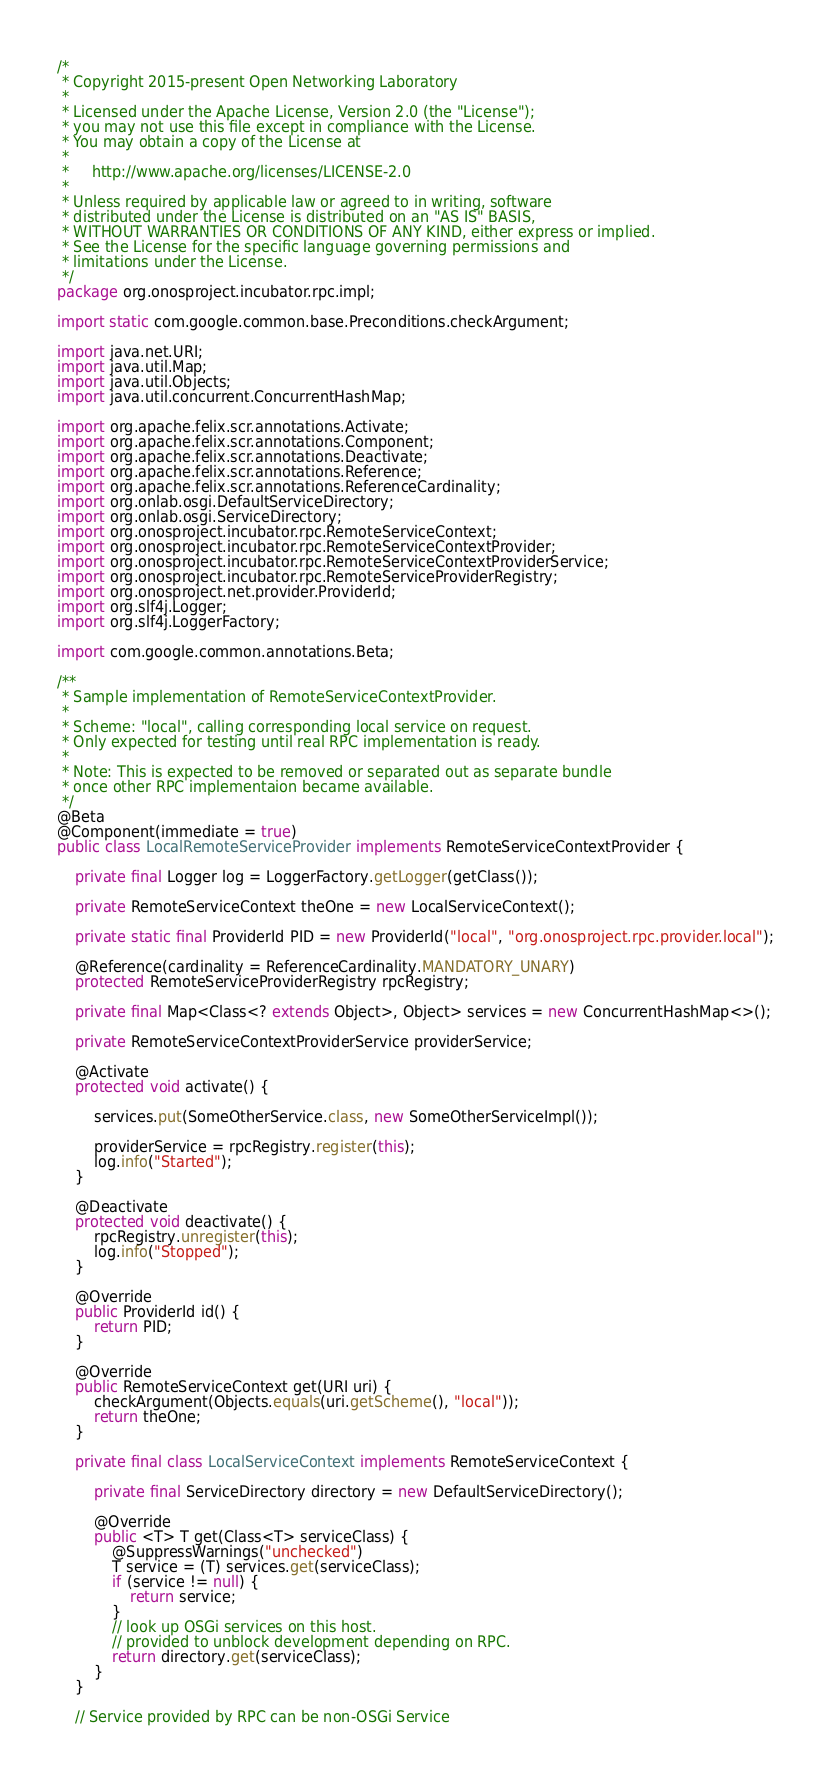<code> <loc_0><loc_0><loc_500><loc_500><_Java_>/*
 * Copyright 2015-present Open Networking Laboratory
 *
 * Licensed under the Apache License, Version 2.0 (the "License");
 * you may not use this file except in compliance with the License.
 * You may obtain a copy of the License at
 *
 *     http://www.apache.org/licenses/LICENSE-2.0
 *
 * Unless required by applicable law or agreed to in writing, software
 * distributed under the License is distributed on an "AS IS" BASIS,
 * WITHOUT WARRANTIES OR CONDITIONS OF ANY KIND, either express or implied.
 * See the License for the specific language governing permissions and
 * limitations under the License.
 */
package org.onosproject.incubator.rpc.impl;

import static com.google.common.base.Preconditions.checkArgument;

import java.net.URI;
import java.util.Map;
import java.util.Objects;
import java.util.concurrent.ConcurrentHashMap;

import org.apache.felix.scr.annotations.Activate;
import org.apache.felix.scr.annotations.Component;
import org.apache.felix.scr.annotations.Deactivate;
import org.apache.felix.scr.annotations.Reference;
import org.apache.felix.scr.annotations.ReferenceCardinality;
import org.onlab.osgi.DefaultServiceDirectory;
import org.onlab.osgi.ServiceDirectory;
import org.onosproject.incubator.rpc.RemoteServiceContext;
import org.onosproject.incubator.rpc.RemoteServiceContextProvider;
import org.onosproject.incubator.rpc.RemoteServiceContextProviderService;
import org.onosproject.incubator.rpc.RemoteServiceProviderRegistry;
import org.onosproject.net.provider.ProviderId;
import org.slf4j.Logger;
import org.slf4j.LoggerFactory;

import com.google.common.annotations.Beta;

/**
 * Sample implementation of RemoteServiceContextProvider.
 *
 * Scheme: "local", calling corresponding local service on request.
 * Only expected for testing until real RPC implementation is ready.
 *
 * Note: This is expected to be removed or separated out as separate bundle
 * once other RPC implementaion became available.
 */
@Beta
@Component(immediate = true)
public class LocalRemoteServiceProvider implements RemoteServiceContextProvider {

    private final Logger log = LoggerFactory.getLogger(getClass());

    private RemoteServiceContext theOne = new LocalServiceContext();

    private static final ProviderId PID = new ProviderId("local", "org.onosproject.rpc.provider.local");

    @Reference(cardinality = ReferenceCardinality.MANDATORY_UNARY)
    protected RemoteServiceProviderRegistry rpcRegistry;

    private final Map<Class<? extends Object>, Object> services = new ConcurrentHashMap<>();

    private RemoteServiceContextProviderService providerService;

    @Activate
    protected void activate() {

        services.put(SomeOtherService.class, new SomeOtherServiceImpl());

        providerService = rpcRegistry.register(this);
        log.info("Started");
    }

    @Deactivate
    protected void deactivate() {
        rpcRegistry.unregister(this);
        log.info("Stopped");
    }

    @Override
    public ProviderId id() {
        return PID;
    }

    @Override
    public RemoteServiceContext get(URI uri) {
        checkArgument(Objects.equals(uri.getScheme(), "local"));
        return theOne;
    }

    private final class LocalServiceContext implements RemoteServiceContext {

        private final ServiceDirectory directory = new DefaultServiceDirectory();

        @Override
        public <T> T get(Class<T> serviceClass) {
            @SuppressWarnings("unchecked")
            T service = (T) services.get(serviceClass);
            if (service != null) {
                return service;
            }
            // look up OSGi services on this host.
            // provided to unblock development depending on RPC.
            return directory.get(serviceClass);
        }
    }

    // Service provided by RPC can be non-OSGi Service</code> 